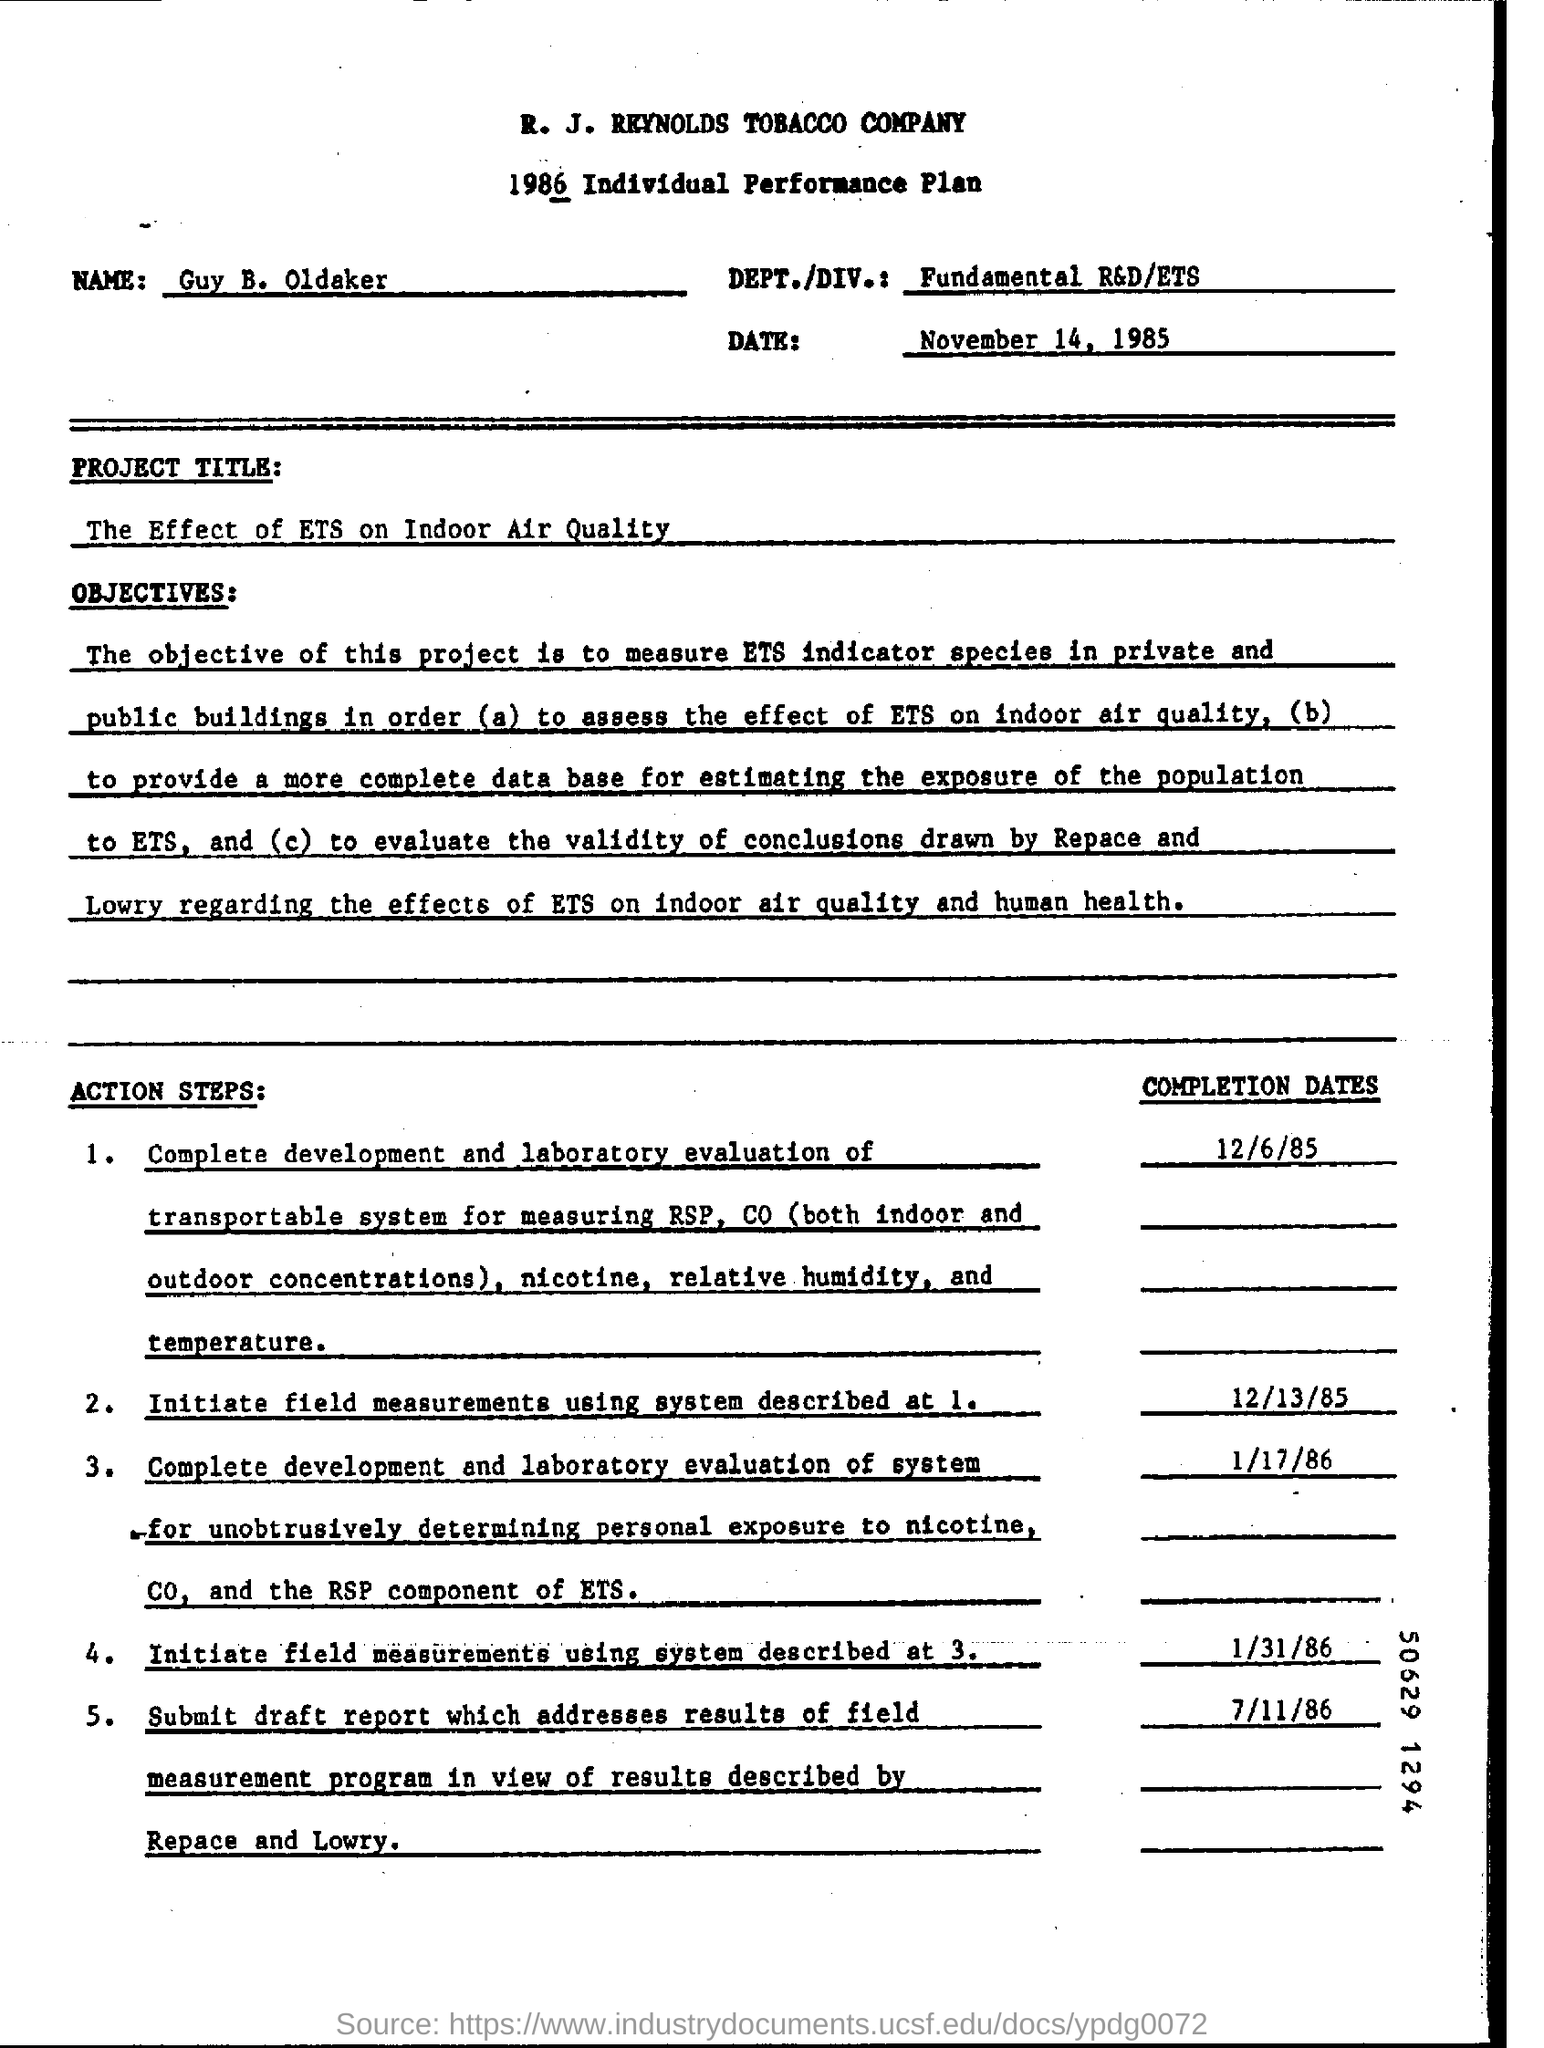What is the document?
Provide a short and direct response. 1986 Individual Performance Plan. What is the name given?
Offer a terse response. Guy B. Oldaker. When is the document dated?
Provide a succinct answer. November 14, 1985. Which is the DEPT./DIV.?
Your answer should be very brief. Fundamental R&D/ETS. What is the project title?
Ensure brevity in your answer.  The Effect of ETS on Indoor Air Quality. 